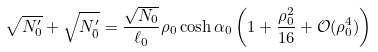Convert formula to latex. <formula><loc_0><loc_0><loc_500><loc_500>\sqrt { N ^ { \prime } _ { 0 } } + \sqrt { N ^ { \prime } _ { \bar { 0 } } } = \frac { \sqrt { N _ { 0 } } } { \ell _ { 0 } } \rho _ { 0 } \cosh \alpha _ { 0 } \left ( 1 + \frac { \rho _ { 0 } ^ { 2 } } { 1 6 } + \mathcal { O } ( \rho _ { 0 } ^ { 4 } ) \right )</formula> 